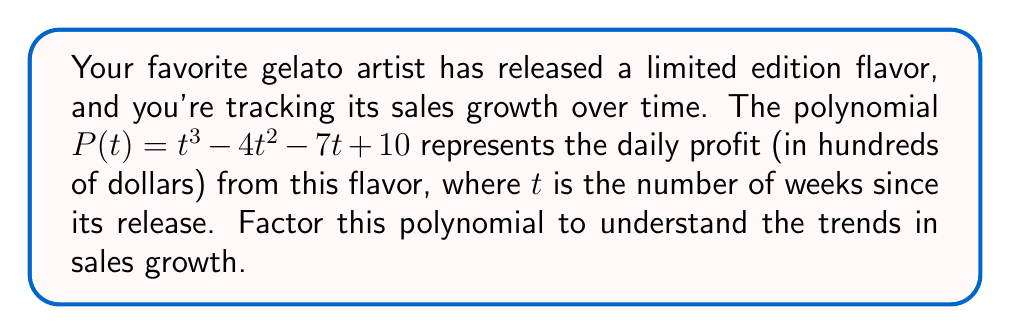Teach me how to tackle this problem. To factor this polynomial, we'll follow these steps:

1) First, let's check if there are any rational roots using the rational root theorem. The possible rational roots are the factors of the constant term: $\pm 1, \pm 2, \pm 5, \pm 10$.

2) Testing these values, we find that $P(1) = 0$. So $(t-1)$ is a factor.

3) We can use polynomial long division to divide $P(t)$ by $(t-1)$:

   $t^3 - 4t^2 - 7t + 10 = (t-1)(t^2 - 3t - 10)$

4) Now we need to factor the quadratic $t^2 - 3t - 10$. We can do this by finding two numbers that multiply to give $-10$ and add to give $-3$. These numbers are $-5$ and $2$.

5) Therefore, $t^2 - 3t - 10 = (t-5)(t+2)$

6) Combining all factors, we get:

   $P(t) = (t-1)(t-5)(t+2)$

This factorization shows that the profit function has three roots: at 1 week, 5 weeks, and -2 weeks (which is not relevant in this context as time can't be negative).
Answer: $(t-1)(t-5)(t+2)$ 